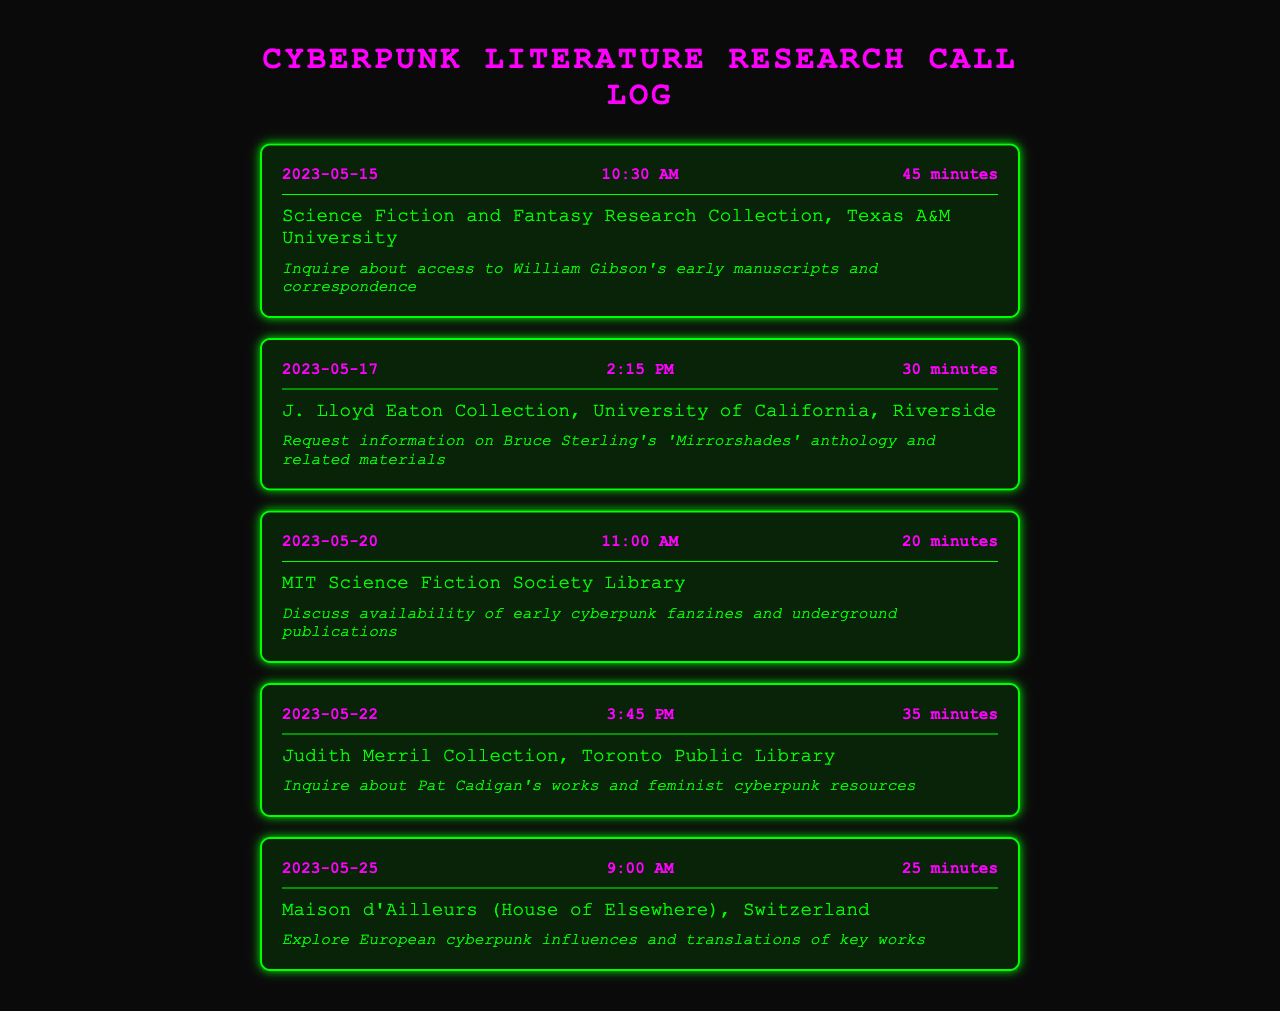What is the date of the first call? The date of the first call is the earliest date listed in the document, which is 2023-05-15.
Answer: 2023-05-15 What was the duration of the call made on May 20th? The duration is one of the attributes noted in the call log for that date, which is 20 minutes.
Answer: 20 minutes Who did the researcher contact on May 25th? The contact information is specified for the call made on that date, which is Maison d'Ailleurs (House of Elsewhere), Switzerland.
Answer: Maison d'Ailleurs (House of Elsewhere), Switzerland What was the purpose of the call made to the Judith Merril Collection? The purpose of the call is described in the document, which is to inquire about Pat Cadigan's works and feminist cyberpunk resources.
Answer: Inquire about Pat Cadigan's works and feminist cyberpunk resources How many minutes did the researcher spend talking on the call with the J. Lloyd Eaton Collection? The duration of the call is specifically noted, which is 30 minutes.
Answer: 30 minutes Which library focuses on science fiction and fantasy research? The library specializing in science fiction and fantasy research is mentioned in the call log, which is Science Fiction and Fantasy Research Collection, Texas A&M University.
Answer: Science Fiction and Fantasy Research Collection, Texas A&M University How many calls were made in total as listed in the document? The total number of calls can be counted by looking at the number of call logs provided, which is five.
Answer: 5 What was discussed during the call with the MIT Science Fiction Society Library? The document indicates the discussion topic for that call, which was availability of early cyberpunk fanzines and underground publications.
Answer: Discuss availability of early cyberpunk fanzines and underground publications On which date was the call made to inquire about Bruce Sterling's work? The call date is clearly indicated, which is 2023-05-17.
Answer: 2023-05-17 